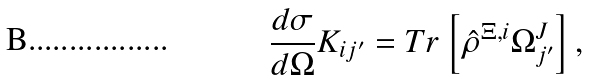<formula> <loc_0><loc_0><loc_500><loc_500>\frac { d \sigma } { d \Omega } K _ { i j ^ { \prime } } = T r \left [ \hat { \rho } ^ { \Xi , i } \Omega ^ { J } _ { j ^ { \prime } } \right ] ,</formula> 